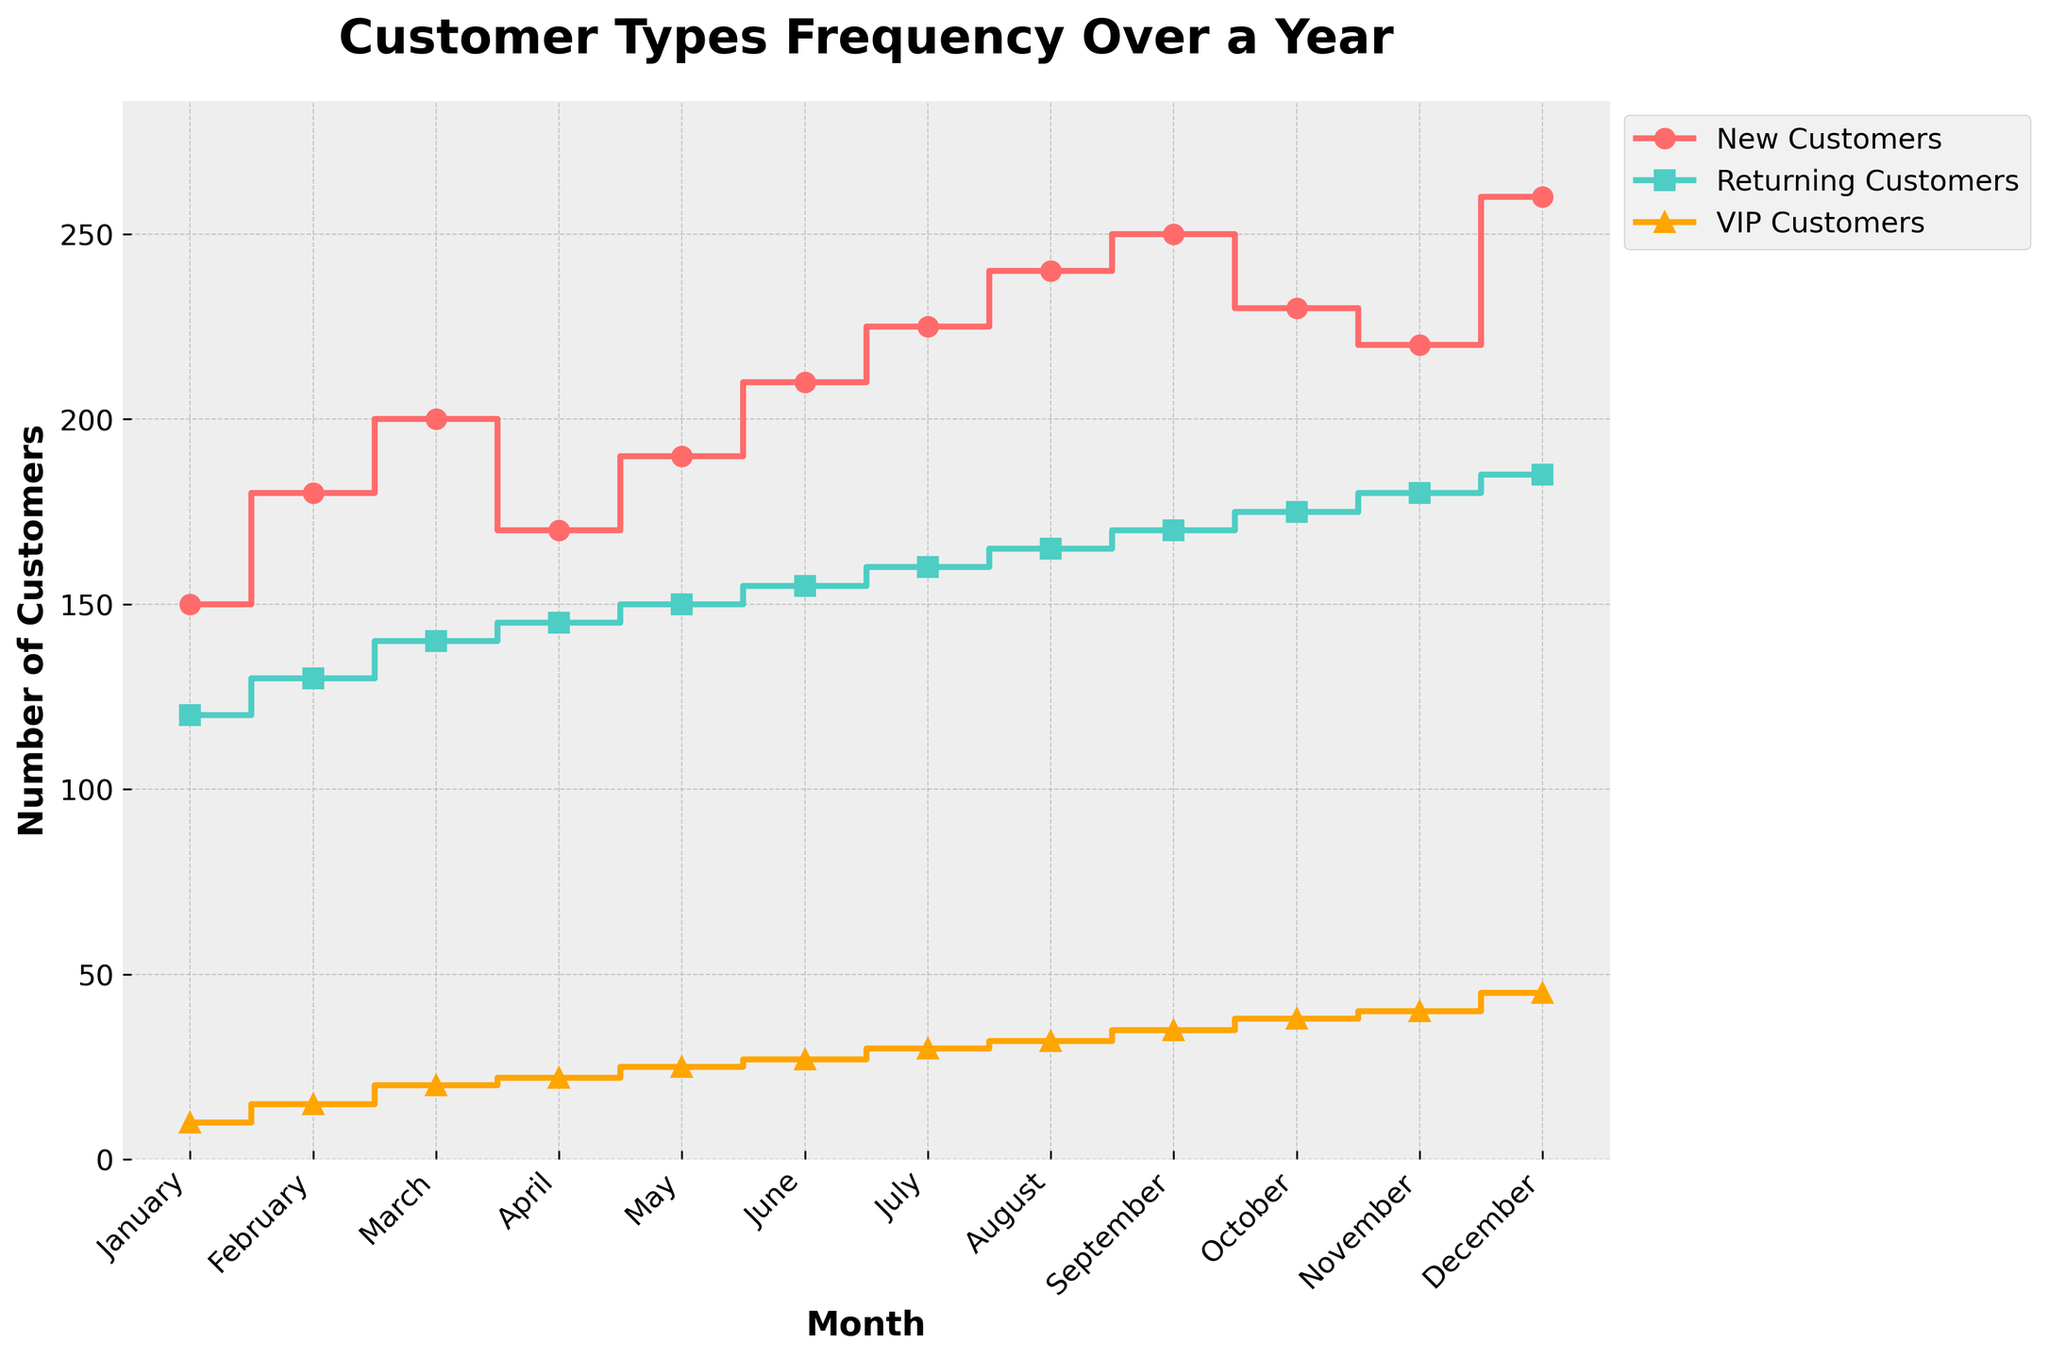What is the title of the figure? The title of the figure is found at the top and is visually distinct as it is in a larger, bold font. It states the main topic or summary of the plotted data.
Answer: Customer Types Frequency Over a Year How many customer types are displayed in the figure? The figure shows three customer types, each represented by a distinct line with different colors and markers.
Answer: 3 Which month has the highest number of VIP Customers? By examining the trend lines for each month, the peak point on the VIP Customers line indicates the highest value. This is found in December.
Answer: December In which month does the number of New Customers start to consistently exceed 200? By looking at the New Customers line and identifying the point where it first surpasses and continues above the 200 mark, we find it occurs in June.
Answer: June What is the difference between the number of Returning Customers and VIP Customers in November? To find this, locate the November values for both Returning Customers and VIP Customers, then subtract the VIP value from the Returning value. Returning Customers in November are 180 and VIP Customers are 40. The difference is 180 - 40.
Answer: 140 What trend do you observe in the number of New Customers from August to December? By looking at the New Customers line from August to December, it shows a generally increasing trend, peaking in December.
Answer: Increasing Which customer type has the least fluctuation throughout the year? By comparing the lines' variation in heights and slope changes over the months, the VIP Customers line shows the least fluctuation compared to the more variable New and Returning Customers lines.
Answer: VIP Customers How does the number of Returning Customers in March compare to New Customers in March? Locate the values for March on both the Returning Customers and New Customers lines, then compare them. Returning Customers are at 140 and New Customers are at 200, so New Customers are higher.
Answer: New Customers are higher What is the combined total of New, Returning, and VIP Customers in October? Locate the values for October and add them together: New Customers (230), Returning Customers (175), and VIP Customers (38). The total is 230 + 175 + 38.
Answer: 443 During which month is the gap between New Customers and VIP Customers the smallest? Compare the difference between New Customers and VIP Customers for each month. The smallest difference occurs in January, where New Customers are 150 and VIP Customers are 10, with a gap of 140.
Answer: January 